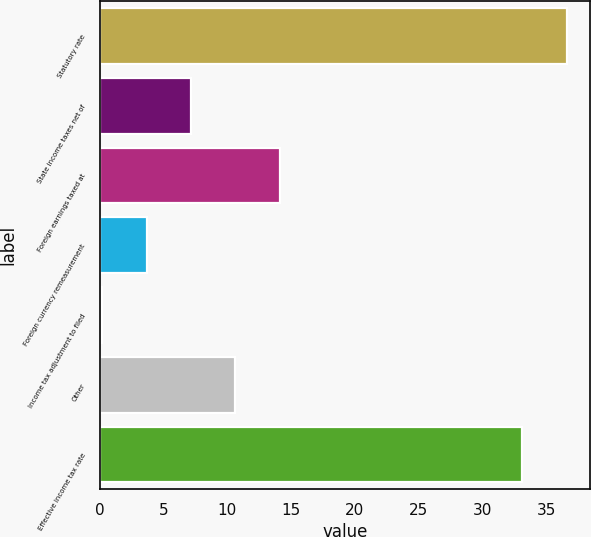<chart> <loc_0><loc_0><loc_500><loc_500><bar_chart><fcel>Statutory rate<fcel>State income taxes net of<fcel>Foreign earnings taxed at<fcel>Foreign currency remeasurement<fcel>Income tax adjustment to filed<fcel>Other<fcel>Effective income tax rate<nl><fcel>36.58<fcel>7.16<fcel>14.12<fcel>3.68<fcel>0.2<fcel>10.64<fcel>33.1<nl></chart> 